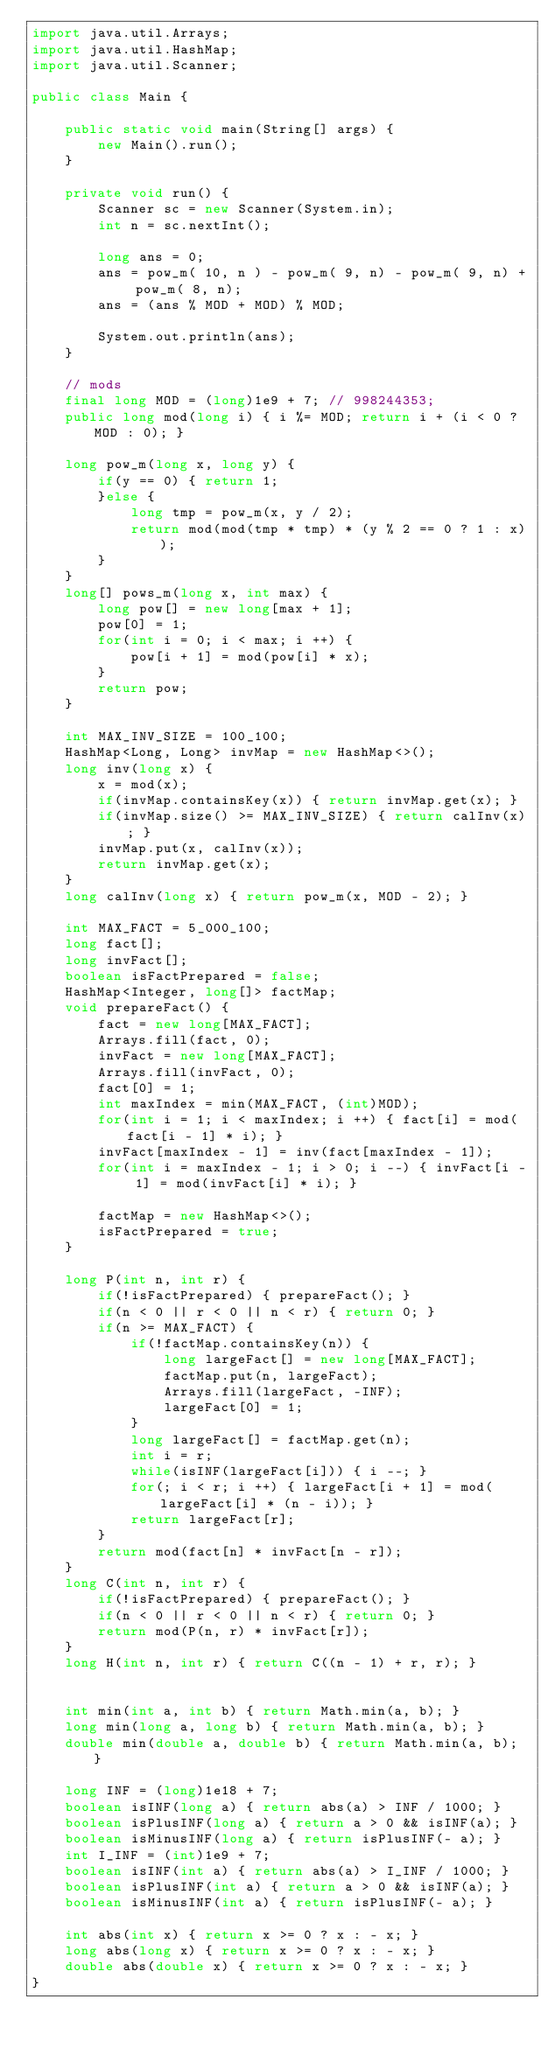Convert code to text. <code><loc_0><loc_0><loc_500><loc_500><_Java_>import java.util.Arrays;
import java.util.HashMap;
import java.util.Scanner;

public class Main {

	public static void main(String[] args) {
		new Main().run();
	}

	private void run() {
		Scanner sc = new Scanner(System.in);
		int n = sc.nextInt();

		long ans = 0;
		ans = pow_m( 10, n ) - pow_m( 9, n) - pow_m( 9, n) + pow_m( 8, n);
		ans = (ans % MOD + MOD) % MOD;
		
		System.out.println(ans);
	}
	
	// mods
	final long MOD = (long)1e9 + 7; // 998244353;
	public long mod(long i) { i %= MOD; return i + (i < 0 ? MOD : 0); }

	long pow_m(long x, long y) {
		if(y == 0) { return 1;
		}else {
			long tmp = pow_m(x, y / 2);
			return mod(mod(tmp * tmp) * (y % 2 == 0 ? 1 : x));
		}
	}
	long[] pows_m(long x, int max) {
		long pow[] = new long[max + 1];
		pow[0] = 1;
		for(int i = 0; i < max; i ++) {
			pow[i + 1] = mod(pow[i] * x);
		}
		return pow;
	}

	int MAX_INV_SIZE = 100_100;
	HashMap<Long, Long> invMap = new HashMap<>();
	long inv(long x) {
		x = mod(x);
		if(invMap.containsKey(x)) { return invMap.get(x); }
		if(invMap.size() >= MAX_INV_SIZE) { return calInv(x); }
		invMap.put(x, calInv(x));
		return invMap.get(x);
	}
	long calInv(long x) { return pow_m(x, MOD - 2); }

	int MAX_FACT = 5_000_100;
	long fact[];
	long invFact[];
	boolean isFactPrepared = false;
	HashMap<Integer, long[]> factMap;
	void prepareFact() {
		fact = new long[MAX_FACT];
		Arrays.fill(fact, 0);
		invFact = new long[MAX_FACT];
		Arrays.fill(invFact, 0);
		fact[0] = 1;
		int maxIndex = min(MAX_FACT, (int)MOD);
		for(int i = 1; i < maxIndex; i ++) { fact[i] = mod(fact[i - 1] * i); }
		invFact[maxIndex - 1] = inv(fact[maxIndex - 1]);
		for(int i = maxIndex - 1; i > 0; i --) { invFact[i - 1] = mod(invFact[i] * i); }

		factMap = new HashMap<>();
		isFactPrepared = true;
	}

	long P(int n, int r) {
		if(!isFactPrepared) { prepareFact(); }
		if(n < 0 || r < 0 || n < r) { return 0; }
		if(n >= MAX_FACT) {
			if(!factMap.containsKey(n)) {
				long largeFact[] = new long[MAX_FACT];
				factMap.put(n, largeFact);
				Arrays.fill(largeFact, -INF);
				largeFact[0] = 1;
			}
			long largeFact[] = factMap.get(n);
			int i = r;
			while(isINF(largeFact[i])) { i --; }
			for(; i < r; i ++) { largeFact[i + 1] = mod(largeFact[i] * (n - i)); }
			return largeFact[r];
		}
		return mod(fact[n] * invFact[n - r]);
	}
	long C(int n, int r) {
		if(!isFactPrepared) { prepareFact(); }
		if(n < 0 || r < 0 || n < r) { return 0; }
		return mod(P(n, r) * invFact[r]);
	}
	long H(int n, int r) { return C((n - 1) + r, r); }


	int min(int a, int b) { return Math.min(a, b); }
	long min(long a, long b) { return Math.min(a, b); }
	double min(double a, double b) { return Math.min(a, b); }
	
	long INF = (long)1e18 + 7;
	boolean isINF(long a) { return abs(a) > INF / 1000; }
	boolean isPlusINF(long a) { return a > 0 && isINF(a); }
	boolean isMinusINF(long a) { return isPlusINF(- a); }
	int I_INF = (int)1e9 + 7;
	boolean isINF(int a) { return abs(a) > I_INF / 1000; }
	boolean isPlusINF(int a) { return a > 0 && isINF(a); }
	boolean isMinusINF(int a) { return isPlusINF(- a); }
	
	int abs(int x) { return x >= 0 ? x : - x; }
	long abs(long x) { return x >= 0 ? x : - x; }
	double abs(double x) { return x >= 0 ? x : - x; }
}</code> 